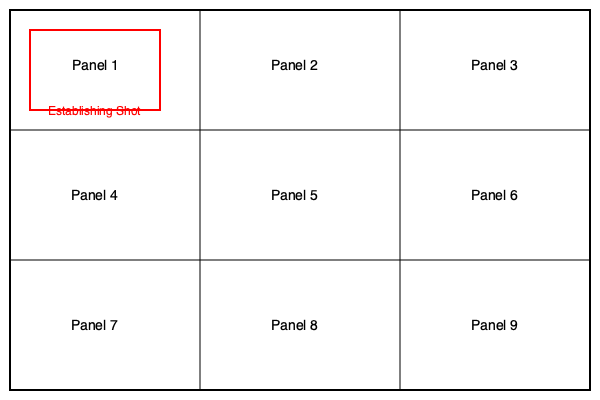In the given storyboard layout, which panel would be most appropriate for an establishing shot in a documentary about a local community, and why is this composition technique important for storytelling in visual media? 1. Analyze the storyboard layout:
   - The layout consists of 9 panels arranged in a 3x3 grid.
   - Panel 1 (top-left) is highlighted in red and labeled "Establishing Shot."

2. Understanding the establishing shot:
   - An establishing shot is typically a wide-angle view that shows the context or setting of a scene.
   - It's usually placed at the beginning of a sequence to orient the viewer.

3. Importance of panel placement:
   - Panel 1 is in the top-left corner, which is where Western audiences typically start reading/viewing.
   - This placement makes it ideal for introducing the setting or context.

4. Composition technique significance:
   - Establishing shots provide visual context for the story.
   - They help viewers understand the environment where the action takes place.
   - In documentaries, they can showcase the community's landscape, architecture, or general atmosphere.

5. Storytelling impact:
   - Sets the tone and mood for the subsequent scenes.
   - Helps viewers connect emotionally with the location.
   - Provides a reference point for more detailed shots that follow.

6. Documentary relevance:
   - For a local community documentary, an establishing shot could show the town's skyline, main street, or a significant landmark.
   - This immediately gives viewers a sense of place and community character.

7. Framing technique:
   - Wide-angle lenses are often used for establishing shots to capture a broad view.
   - The composition often includes foreground, middle ground, and background elements to create depth.

8. Relation to other panels:
   - Subsequent panels can focus on specific details or individuals within the community.
   - The establishing shot provides context for these more focused shots.

Therefore, Panel 1 is most appropriate for an establishing shot, as it introduces the visual narrative and sets the stage for the story to unfold in the following panels.
Answer: Panel 1; it introduces the setting, orients viewers, and provides context for the documentary's narrative. 